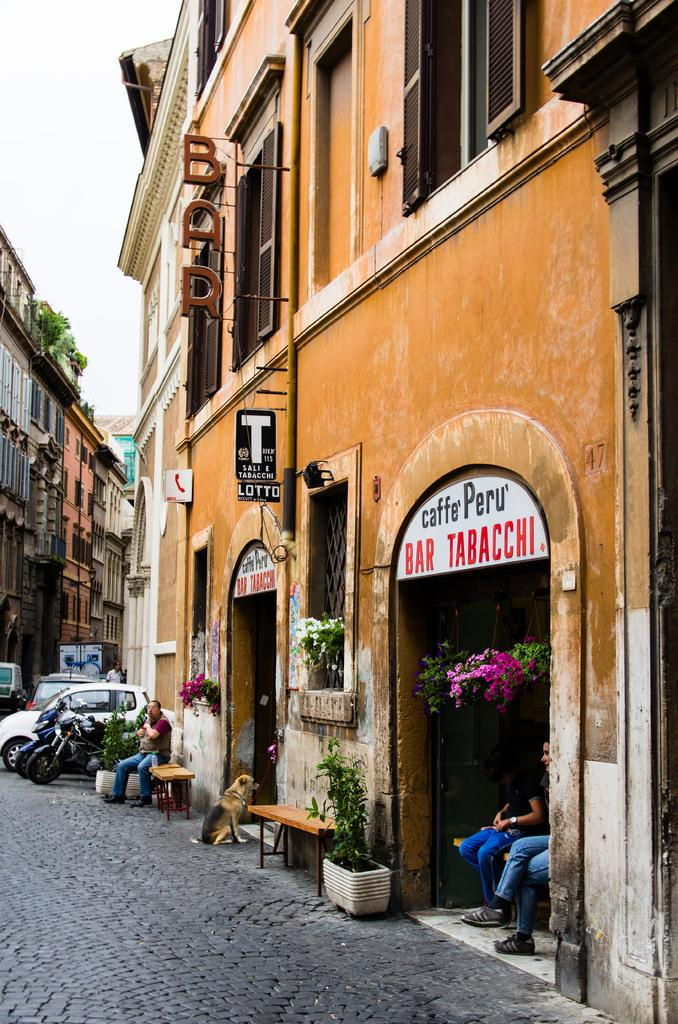How many people are sitting on the bench in the image? There are three persons sitting on a bench in the image. What other living creature is present in the image? There is a dog in the image. What type of structure can be seen in the background? There is a building in the image. What mode of transportation can be seen on the road? Vehicles are visible on the road. What type of vegetation is present in the image? There is a plant in the image. What type of setting is depicted in the image? The image depicts a city setting. What is the opinion of the pig about the city setting in the image? There is no pig present in the image, so it is not possible to determine its opinion about the city setting. 